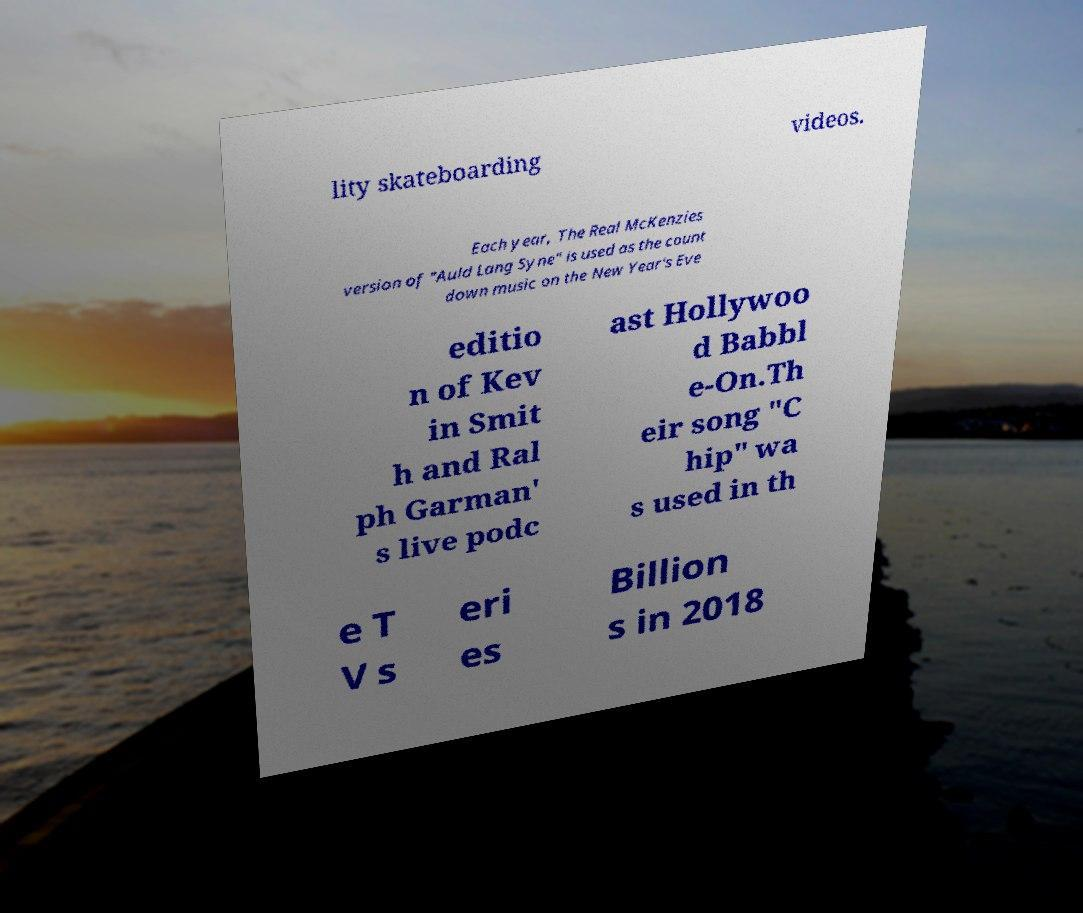Please read and relay the text visible in this image. What does it say? lity skateboarding videos. Each year, The Real McKenzies version of "Auld Lang Syne" is used as the count down music on the New Year's Eve editio n of Kev in Smit h and Ral ph Garman' s live podc ast Hollywoo d Babbl e-On.Th eir song "C hip" wa s used in th e T V s eri es Billion s in 2018 